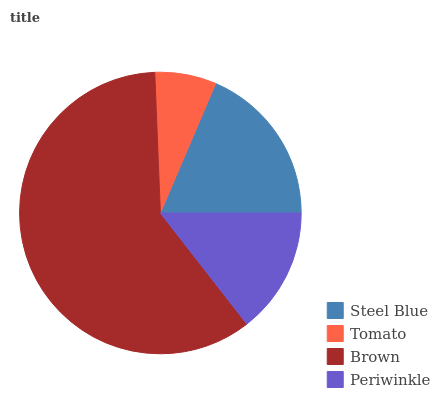Is Tomato the minimum?
Answer yes or no. Yes. Is Brown the maximum?
Answer yes or no. Yes. Is Brown the minimum?
Answer yes or no. No. Is Tomato the maximum?
Answer yes or no. No. Is Brown greater than Tomato?
Answer yes or no. Yes. Is Tomato less than Brown?
Answer yes or no. Yes. Is Tomato greater than Brown?
Answer yes or no. No. Is Brown less than Tomato?
Answer yes or no. No. Is Steel Blue the high median?
Answer yes or no. Yes. Is Periwinkle the low median?
Answer yes or no. Yes. Is Tomato the high median?
Answer yes or no. No. Is Steel Blue the low median?
Answer yes or no. No. 